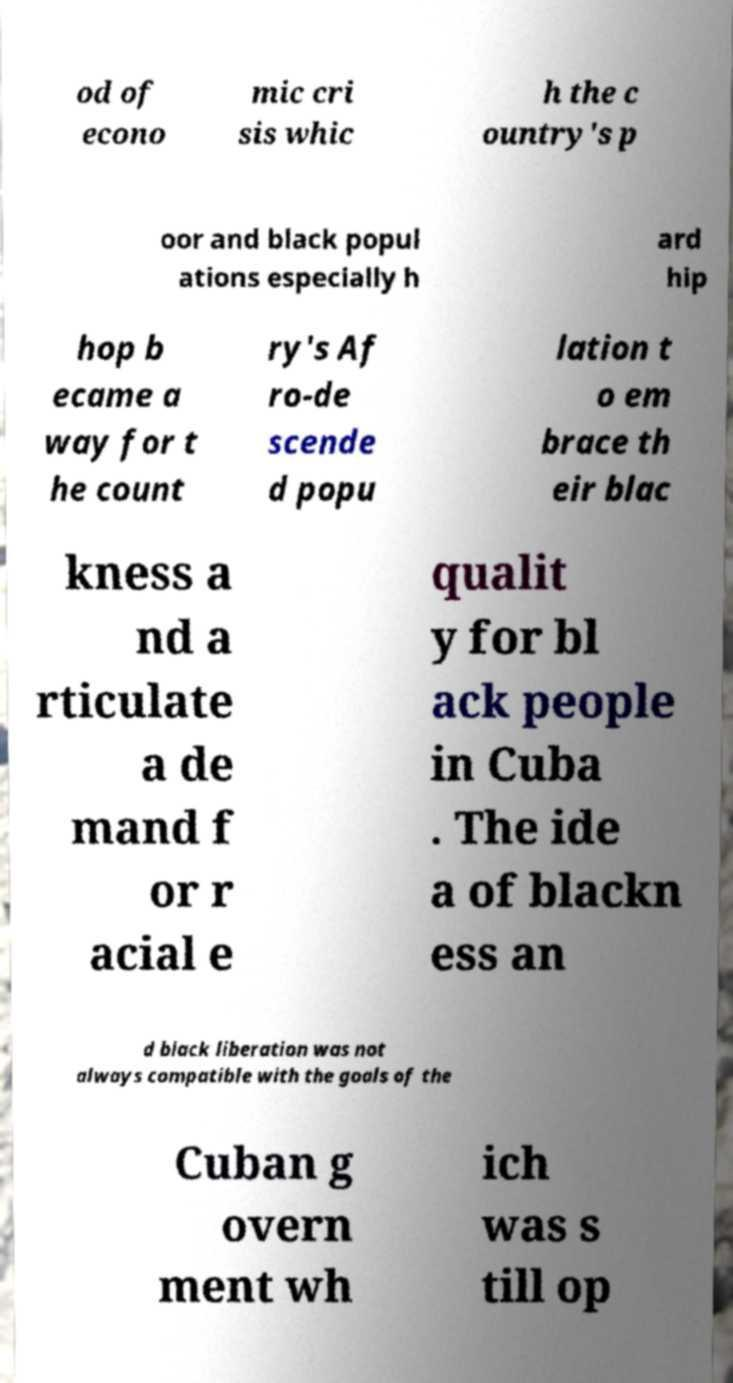For documentation purposes, I need the text within this image transcribed. Could you provide that? od of econo mic cri sis whic h the c ountry's p oor and black popul ations especially h ard hip hop b ecame a way for t he count ry's Af ro-de scende d popu lation t o em brace th eir blac kness a nd a rticulate a de mand f or r acial e qualit y for bl ack people in Cuba . The ide a of blackn ess an d black liberation was not always compatible with the goals of the Cuban g overn ment wh ich was s till op 